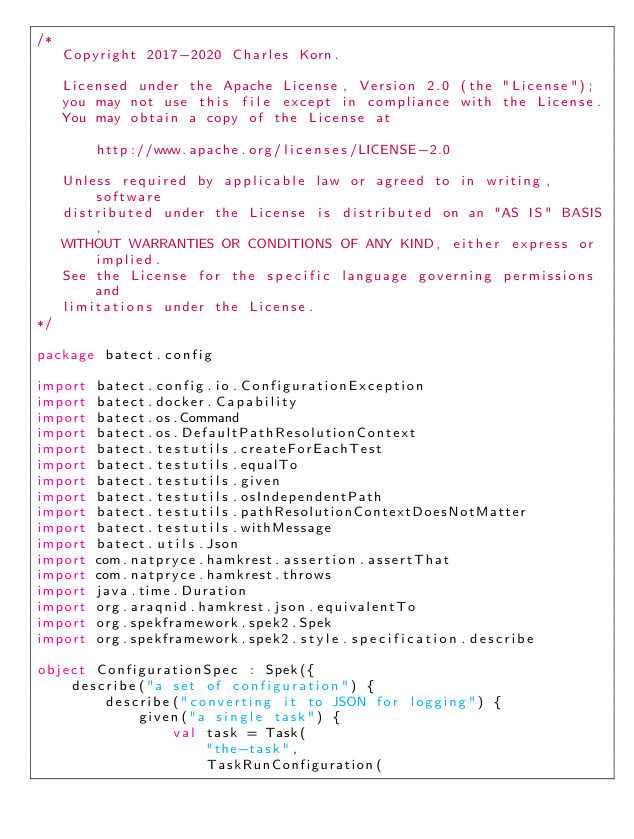<code> <loc_0><loc_0><loc_500><loc_500><_Kotlin_>/*
   Copyright 2017-2020 Charles Korn.

   Licensed under the Apache License, Version 2.0 (the "License");
   you may not use this file except in compliance with the License.
   You may obtain a copy of the License at

       http://www.apache.org/licenses/LICENSE-2.0

   Unless required by applicable law or agreed to in writing, software
   distributed under the License is distributed on an "AS IS" BASIS,
   WITHOUT WARRANTIES OR CONDITIONS OF ANY KIND, either express or implied.
   See the License for the specific language governing permissions and
   limitations under the License.
*/

package batect.config

import batect.config.io.ConfigurationException
import batect.docker.Capability
import batect.os.Command
import batect.os.DefaultPathResolutionContext
import batect.testutils.createForEachTest
import batect.testutils.equalTo
import batect.testutils.given
import batect.testutils.osIndependentPath
import batect.testutils.pathResolutionContextDoesNotMatter
import batect.testutils.withMessage
import batect.utils.Json
import com.natpryce.hamkrest.assertion.assertThat
import com.natpryce.hamkrest.throws
import java.time.Duration
import org.araqnid.hamkrest.json.equivalentTo
import org.spekframework.spek2.Spek
import org.spekframework.spek2.style.specification.describe

object ConfigurationSpec : Spek({
    describe("a set of configuration") {
        describe("converting it to JSON for logging") {
            given("a single task") {
                val task = Task(
                    "the-task",
                    TaskRunConfiguration(</code> 